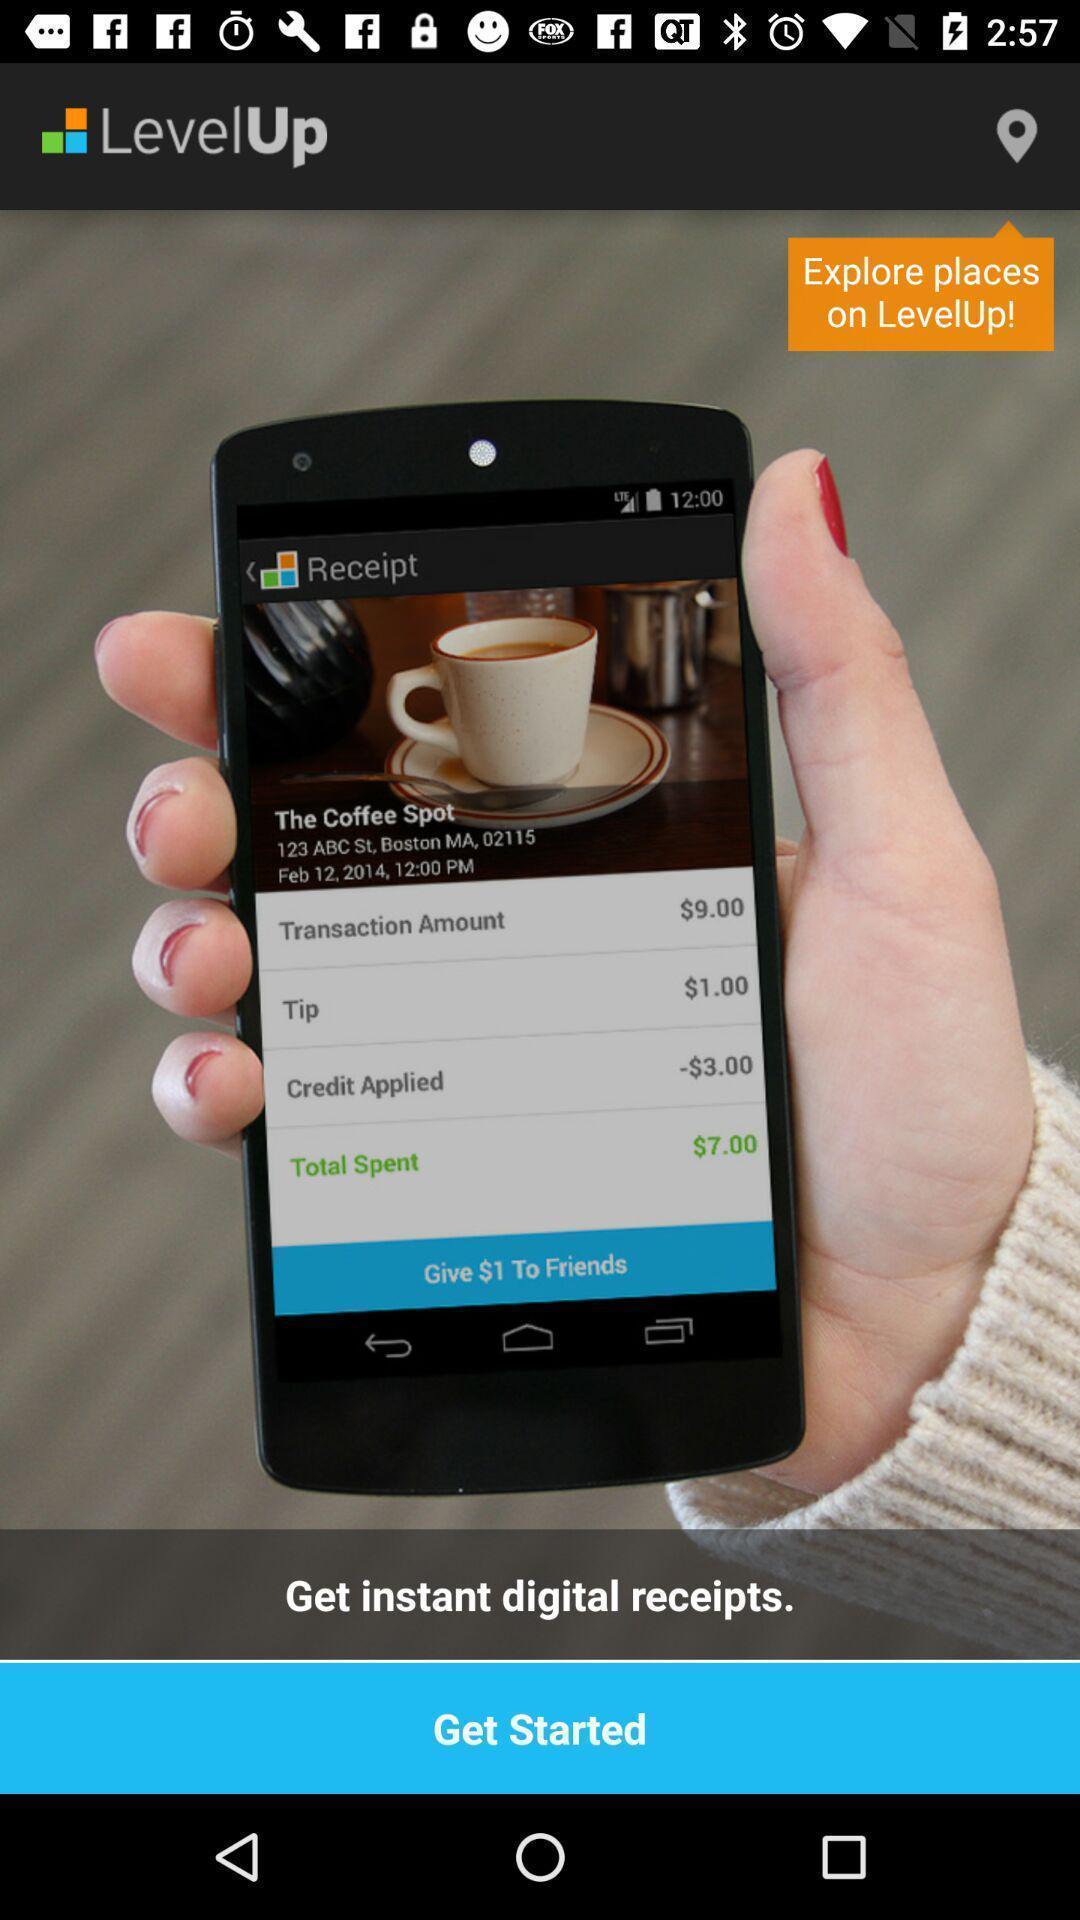Give me a narrative description of this picture. Welcome page for an app. 